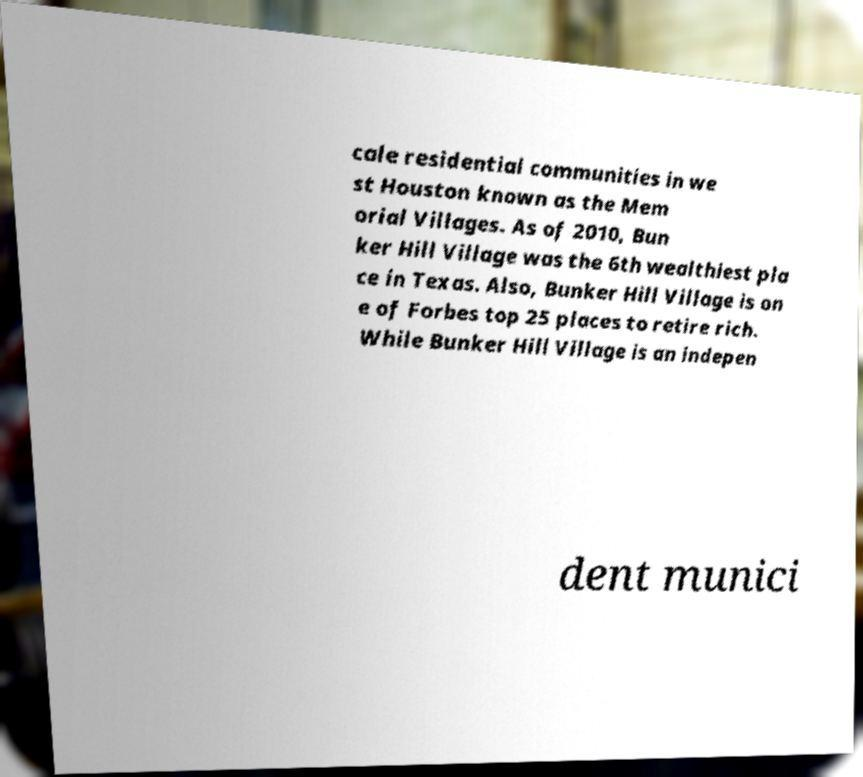Can you read and provide the text displayed in the image?This photo seems to have some interesting text. Can you extract and type it out for me? cale residential communities in we st Houston known as the Mem orial Villages. As of 2010, Bun ker Hill Village was the 6th wealthiest pla ce in Texas. Also, Bunker Hill Village is on e of Forbes top 25 places to retire rich. While Bunker Hill Village is an indepen dent munici 